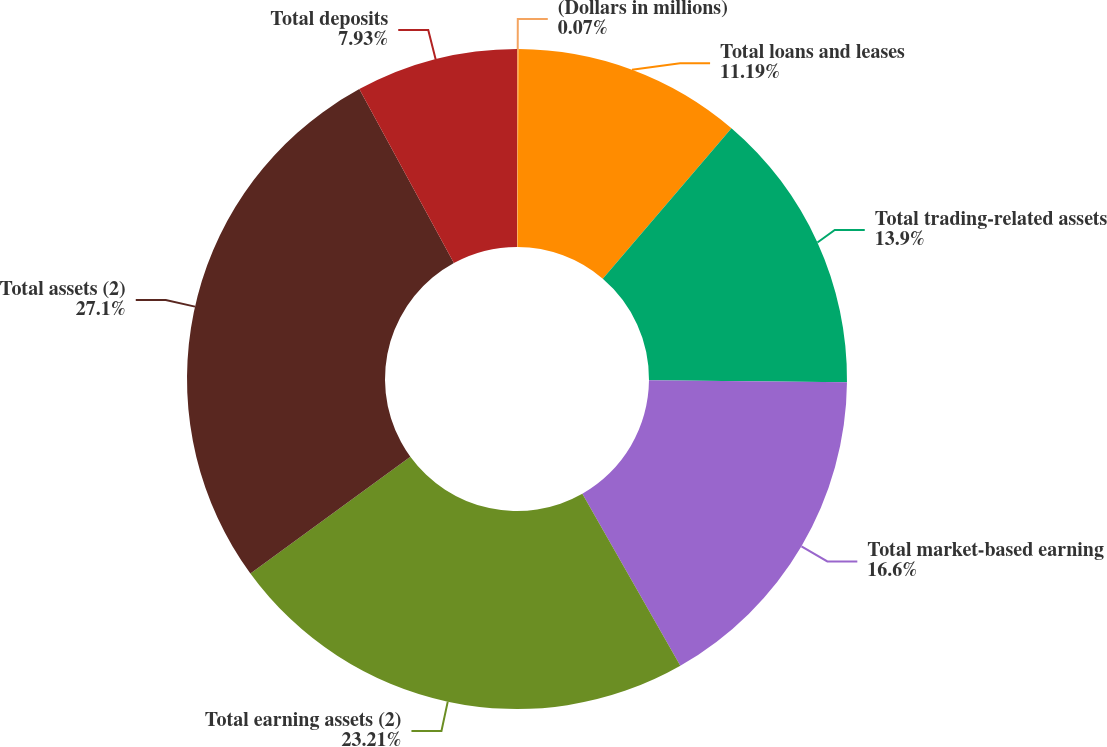Convert chart. <chart><loc_0><loc_0><loc_500><loc_500><pie_chart><fcel>(Dollars in millions)<fcel>Total loans and leases<fcel>Total trading-related assets<fcel>Total market-based earning<fcel>Total earning assets (2)<fcel>Total assets (2)<fcel>Total deposits<nl><fcel>0.07%<fcel>11.19%<fcel>13.9%<fcel>16.6%<fcel>23.21%<fcel>27.1%<fcel>7.93%<nl></chart> 